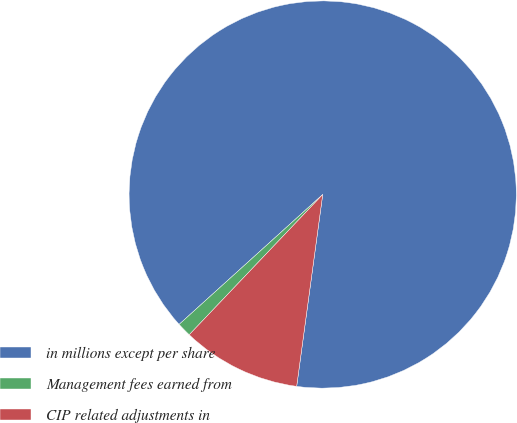<chart> <loc_0><loc_0><loc_500><loc_500><pie_chart><fcel>in millions except per share<fcel>Management fees earned from<fcel>CIP related adjustments in<nl><fcel>88.85%<fcel>1.19%<fcel>9.96%<nl></chart> 